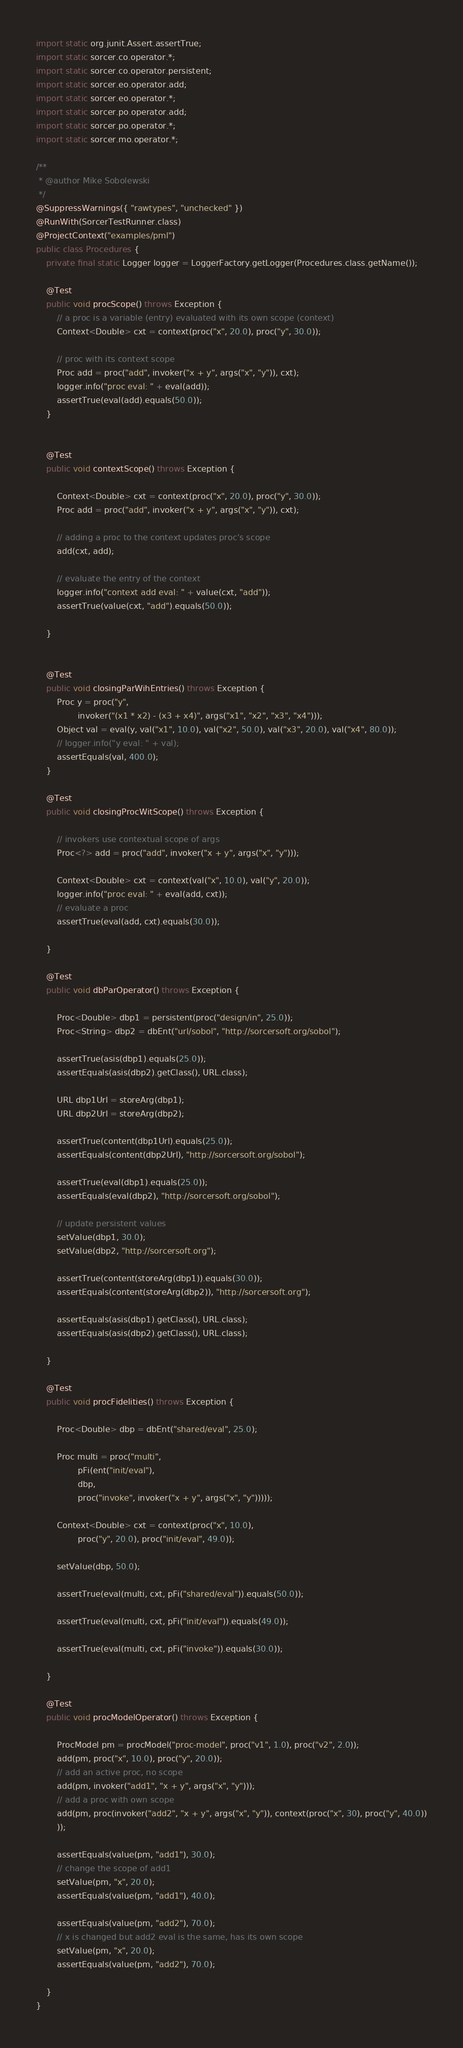<code> <loc_0><loc_0><loc_500><loc_500><_Java_>import static org.junit.Assert.assertTrue;
import static sorcer.co.operator.*;
import static sorcer.co.operator.persistent;
import static sorcer.eo.operator.add;
import static sorcer.eo.operator.*;
import static sorcer.po.operator.add;
import static sorcer.po.operator.*;
import static sorcer.mo.operator.*;

/**
 * @author Mike Sobolewski
 */
@SuppressWarnings({ "rawtypes", "unchecked" })
@RunWith(SorcerTestRunner.class)
@ProjectContext("examples/pml")
public class Procedures {
	private final static Logger logger = LoggerFactory.getLogger(Procedures.class.getName());

	@Test
	public void procScope() throws Exception {
		// a proc is a variable (entry) evaluated with its own scope (context)
		Context<Double> cxt = context(proc("x", 20.0), proc("y", 30.0));

		// proc with its context scope
		Proc add = proc("add", invoker("x + y", args("x", "y")), cxt);
		logger.info("proc eval: " + eval(add));
		assertTrue(eval(add).equals(50.0));
	}


	@Test
	public void contextScope() throws Exception {

		Context<Double> cxt = context(proc("x", 20.0), proc("y", 30.0));
		Proc add = proc("add", invoker("x + y", args("x", "y")), cxt);

		// adding a proc to the context updates proc's scope
		add(cxt, add);

		// evaluate the entry of the context
		logger.info("context add eval: " + value(cxt, "add"));
		assertTrue(value(cxt, "add").equals(50.0));

	}
	
	
	@Test
	public void closingParWihEntries() throws Exception {
		Proc y = proc("y",
				invoker("(x1 * x2) - (x3 + x4)", args("x1", "x2", "x3", "x4")));
		Object val = eval(y, val("x1", 10.0), val("x2", 50.0), val("x3", 20.0), val("x4", 80.0));
		// logger.info("y eval: " + val);
		assertEquals(val, 400.0);
	}

	@Test
	public void closingProcWitScope() throws Exception {

		// invokers use contextual scope of args
		Proc<?> add = proc("add", invoker("x + y", args("x", "y")));

		Context<Double> cxt = context(val("x", 10.0), val("y", 20.0));
		logger.info("proc eval: " + eval(add, cxt));
		// evaluate a proc
		assertTrue(eval(add, cxt).equals(30.0));

	}

	@Test
	public void dbParOperator() throws Exception {	
		
		Proc<Double> dbp1 = persistent(proc("design/in", 25.0));
		Proc<String> dbp2 = dbEnt("url/sobol", "http://sorcersoft.org/sobol");

		assertTrue(asis(dbp1).equals(25.0));
		assertEquals(asis(dbp2).getClass(), URL.class);
			
		URL dbp1Url = storeArg(dbp1);
		URL dbp2Url = storeArg(dbp2);

		assertTrue(content(dbp1Url).equals(25.0));
		assertEquals(content(dbp2Url), "http://sorcersoft.org/sobol");
		
		assertTrue(eval(dbp1).equals(25.0));
		assertEquals(eval(dbp2), "http://sorcersoft.org/sobol");

		// update persistent values
		setValue(dbp1, 30.0);
		setValue(dbp2, "http://sorcersoft.org");
	
		assertTrue(content(storeArg(dbp1)).equals(30.0));
		assertEquals(content(storeArg(dbp2)), "http://sorcersoft.org");

		assertEquals(asis(dbp1).getClass(), URL.class);
		assertEquals(asis(dbp2).getClass(), URL.class);

	}

	@Test
	public void procFidelities() throws Exception {
		
		Proc<Double> dbp = dbEnt("shared/eval", 25.0);
		
		Proc multi = proc("multi",
				pFi(ent("init/eval"),
				dbp,
				proc("invoke", invoker("x + y", args("x", "y")))));
		
		Context<Double> cxt = context(proc("x", 10.0),
				proc("y", 20.0), proc("init/eval", 49.0));
		
		setValue(dbp, 50.0);

		assertTrue(eval(multi, cxt, pFi("shared/eval")).equals(50.0));

		assertTrue(eval(multi, cxt, pFi("init/eval")).equals(49.0));

		assertTrue(eval(multi, cxt, pFi("invoke")).equals(30.0));

	}
	
	@Test
	public void procModelOperator() throws Exception {
		
		ProcModel pm = procModel("proc-model", proc("v1", 1.0), proc("v2", 2.0));
		add(pm, proc("x", 10.0), proc("y", 20.0));
		// add an active proc, no scope
		add(pm, invoker("add1", "x + y", args("x", "y")));
		// add a proc with own scope
		add(pm, proc(invoker("add2", "x + y", args("x", "y")), context(proc("x", 30), proc("y", 40.0))
		));
		
		assertEquals(value(pm, "add1"), 30.0);
		// change the scope of add1
		setValue(pm, "x", 20.0);
		assertEquals(value(pm, "add1"), 40.0);

		assertEquals(value(pm, "add2"), 70.0);
		// x is changed but add2 eval is the same, has its own scope
		setValue(pm, "x", 20.0);
		assertEquals(value(pm, "add2"), 70.0);
		
	}
}
</code> 